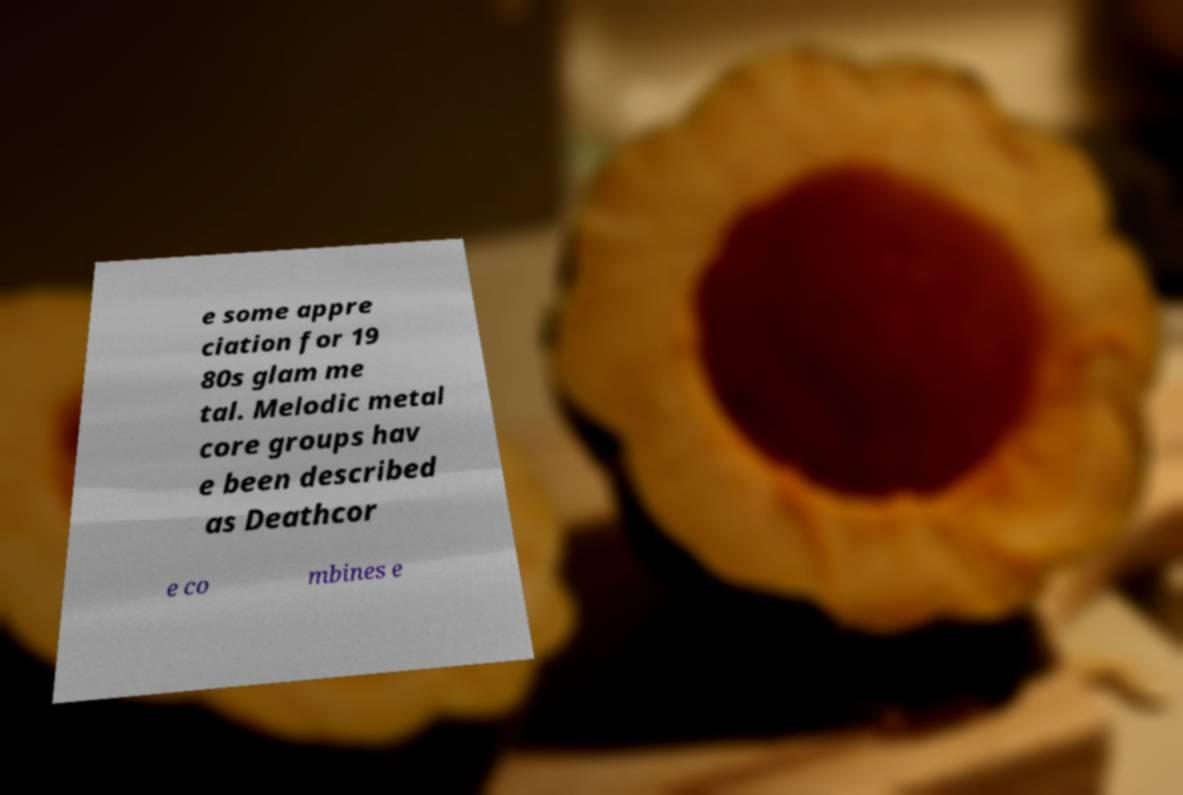Please read and relay the text visible in this image. What does it say? e some appre ciation for 19 80s glam me tal. Melodic metal core groups hav e been described as Deathcor e co mbines e 